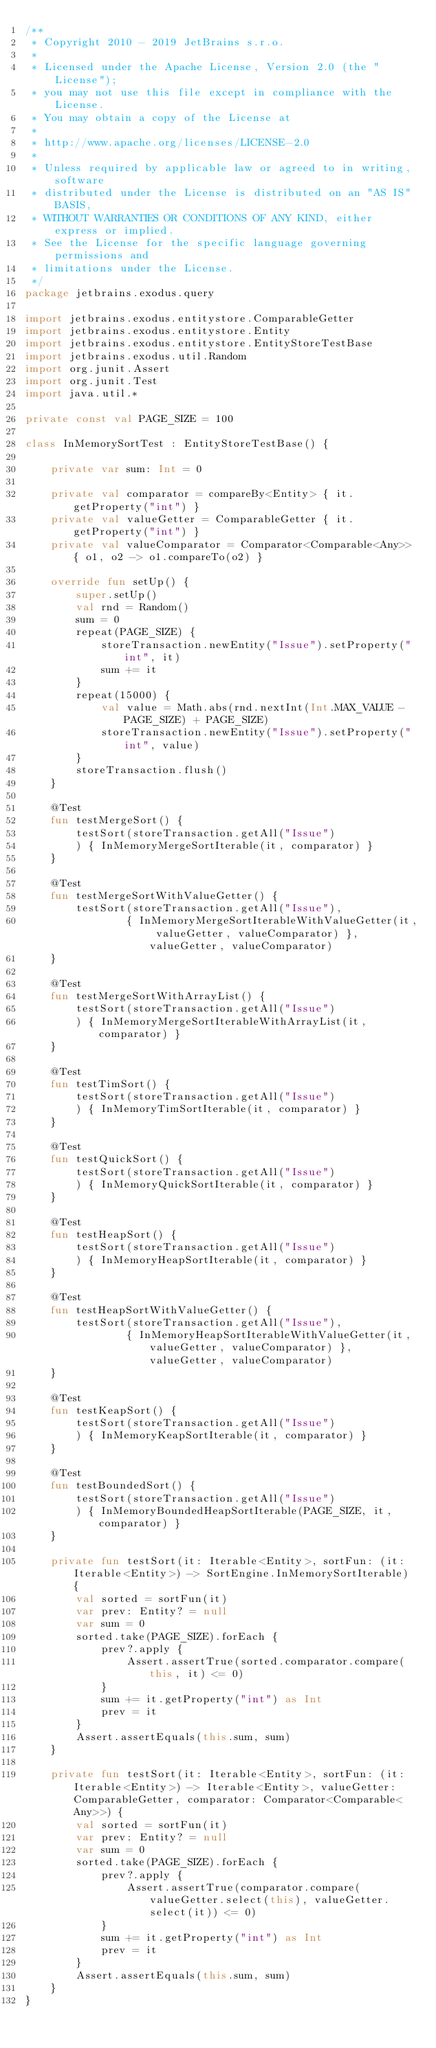<code> <loc_0><loc_0><loc_500><loc_500><_Kotlin_>/**
 * Copyright 2010 - 2019 JetBrains s.r.o.
 *
 * Licensed under the Apache License, Version 2.0 (the "License");
 * you may not use this file except in compliance with the License.
 * You may obtain a copy of the License at
 *
 * http://www.apache.org/licenses/LICENSE-2.0
 *
 * Unless required by applicable law or agreed to in writing, software
 * distributed under the License is distributed on an "AS IS" BASIS,
 * WITHOUT WARRANTIES OR CONDITIONS OF ANY KIND, either express or implied.
 * See the License for the specific language governing permissions and
 * limitations under the License.
 */
package jetbrains.exodus.query

import jetbrains.exodus.entitystore.ComparableGetter
import jetbrains.exodus.entitystore.Entity
import jetbrains.exodus.entitystore.EntityStoreTestBase
import jetbrains.exodus.util.Random
import org.junit.Assert
import org.junit.Test
import java.util.*

private const val PAGE_SIZE = 100

class InMemorySortTest : EntityStoreTestBase() {

    private var sum: Int = 0

    private val comparator = compareBy<Entity> { it.getProperty("int") }
    private val valueGetter = ComparableGetter { it.getProperty("int") }
    private val valueComparator = Comparator<Comparable<Any>> { o1, o2 -> o1.compareTo(o2) }

    override fun setUp() {
        super.setUp()
        val rnd = Random()
        sum = 0
        repeat(PAGE_SIZE) {
            storeTransaction.newEntity("Issue").setProperty("int", it)
            sum += it
        }
        repeat(15000) {
            val value = Math.abs(rnd.nextInt(Int.MAX_VALUE - PAGE_SIZE) + PAGE_SIZE)
            storeTransaction.newEntity("Issue").setProperty("int", value)
        }
        storeTransaction.flush()
    }

    @Test
    fun testMergeSort() {
        testSort(storeTransaction.getAll("Issue")
        ) { InMemoryMergeSortIterable(it, comparator) }
    }

    @Test
    fun testMergeSortWithValueGetter() {
        testSort(storeTransaction.getAll("Issue"),
                { InMemoryMergeSortIterableWithValueGetter(it, valueGetter, valueComparator) }, valueGetter, valueComparator)
    }

    @Test
    fun testMergeSortWithArrayList() {
        testSort(storeTransaction.getAll("Issue")
        ) { InMemoryMergeSortIterableWithArrayList(it, comparator) }
    }

    @Test
    fun testTimSort() {
        testSort(storeTransaction.getAll("Issue")
        ) { InMemoryTimSortIterable(it, comparator) }
    }

    @Test
    fun testQuickSort() {
        testSort(storeTransaction.getAll("Issue")
        ) { InMemoryQuickSortIterable(it, comparator) }
    }

    @Test
    fun testHeapSort() {
        testSort(storeTransaction.getAll("Issue")
        ) { InMemoryHeapSortIterable(it, comparator) }
    }

    @Test
    fun testHeapSortWithValueGetter() {
        testSort(storeTransaction.getAll("Issue"),
                { InMemoryHeapSortIterableWithValueGetter(it, valueGetter, valueComparator) }, valueGetter, valueComparator)
    }

    @Test
    fun testKeapSort() {
        testSort(storeTransaction.getAll("Issue")
        ) { InMemoryKeapSortIterable(it, comparator) }
    }

    @Test
    fun testBoundedSort() {
        testSort(storeTransaction.getAll("Issue")
        ) { InMemoryBoundedHeapSortIterable(PAGE_SIZE, it, comparator) }
    }

    private fun testSort(it: Iterable<Entity>, sortFun: (it: Iterable<Entity>) -> SortEngine.InMemorySortIterable) {
        val sorted = sortFun(it)
        var prev: Entity? = null
        var sum = 0
        sorted.take(PAGE_SIZE).forEach {
            prev?.apply {
                Assert.assertTrue(sorted.comparator.compare(this, it) <= 0)
            }
            sum += it.getProperty("int") as Int
            prev = it
        }
        Assert.assertEquals(this.sum, sum)
    }

    private fun testSort(it: Iterable<Entity>, sortFun: (it: Iterable<Entity>) -> Iterable<Entity>, valueGetter: ComparableGetter, comparator: Comparator<Comparable<Any>>) {
        val sorted = sortFun(it)
        var prev: Entity? = null
        var sum = 0
        sorted.take(PAGE_SIZE).forEach {
            prev?.apply {
                Assert.assertTrue(comparator.compare(valueGetter.select(this), valueGetter.select(it)) <= 0)
            }
            sum += it.getProperty("int") as Int
            prev = it
        }
        Assert.assertEquals(this.sum, sum)
    }
}
</code> 